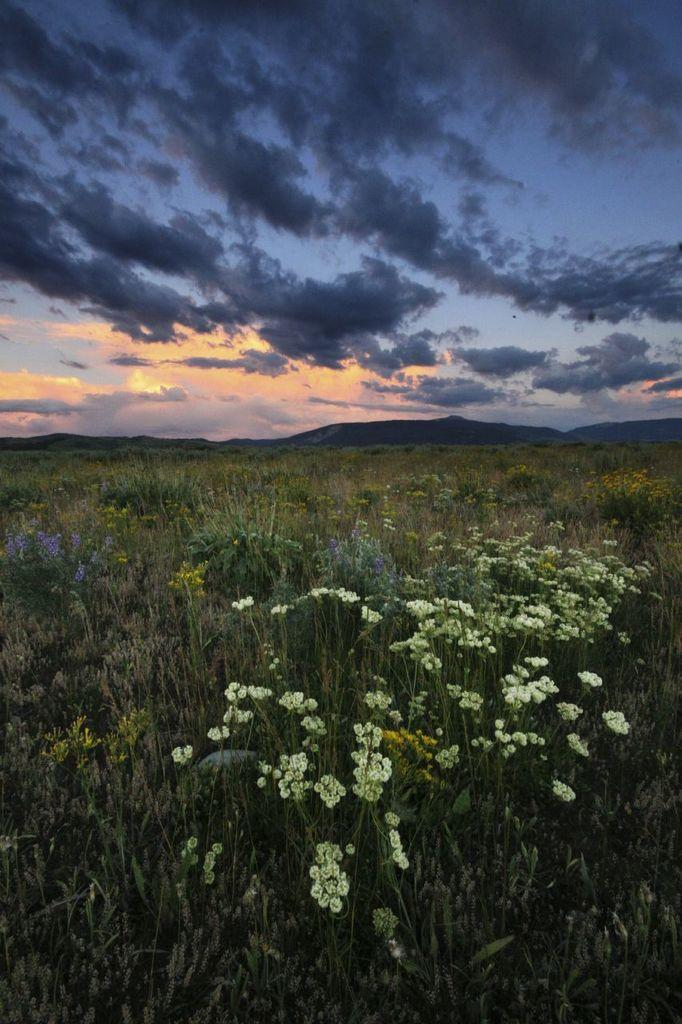What type of vegetation is present on the ground in the image? There are plants on the ground in the image. What can be seen in the sky in the image? There are clouds visible in the sky in the image. Where is the faucet located in the image? There is no faucet present in the image. Are there any spies visible in the image? There are no spies present in the image. 